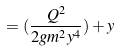Convert formula to latex. <formula><loc_0><loc_0><loc_500><loc_500>= ( \frac { Q ^ { 2 } } { 2 g m ^ { 2 } y ^ { 4 } } ) + y</formula> 